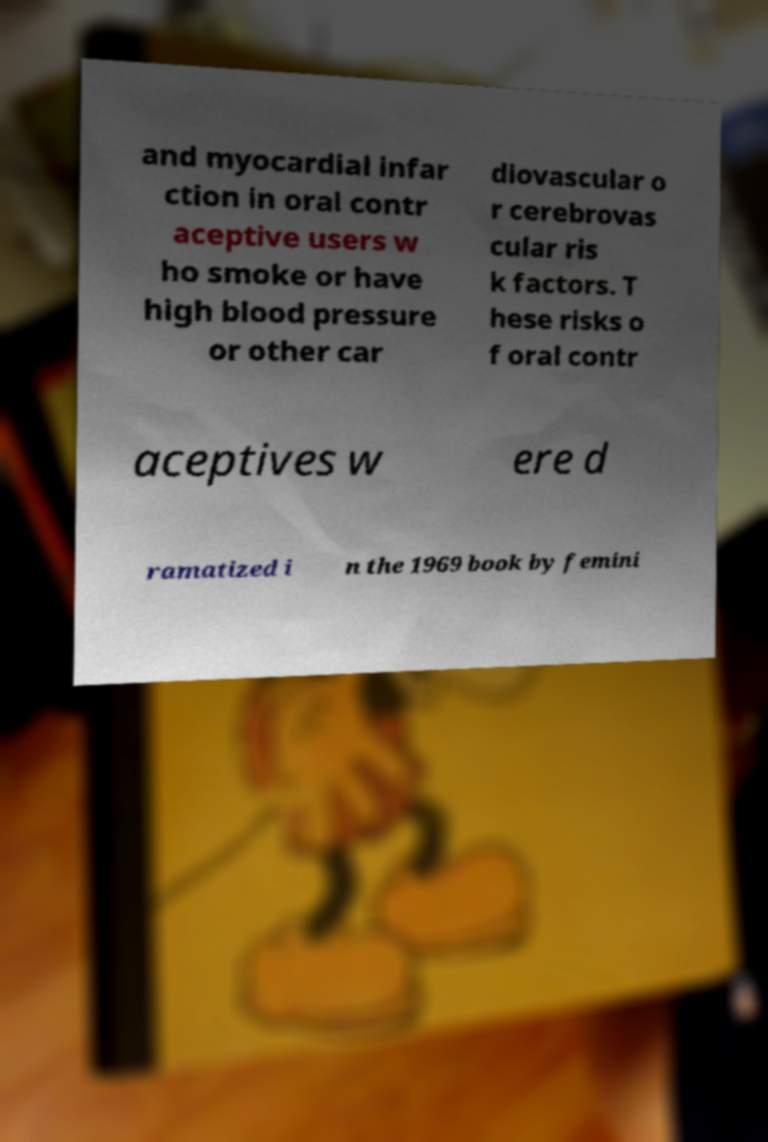Can you read and provide the text displayed in the image?This photo seems to have some interesting text. Can you extract and type it out for me? and myocardial infar ction in oral contr aceptive users w ho smoke or have high blood pressure or other car diovascular o r cerebrovas cular ris k factors. T hese risks o f oral contr aceptives w ere d ramatized i n the 1969 book by femini 